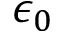<formula> <loc_0><loc_0><loc_500><loc_500>\epsilon _ { 0 }</formula> 